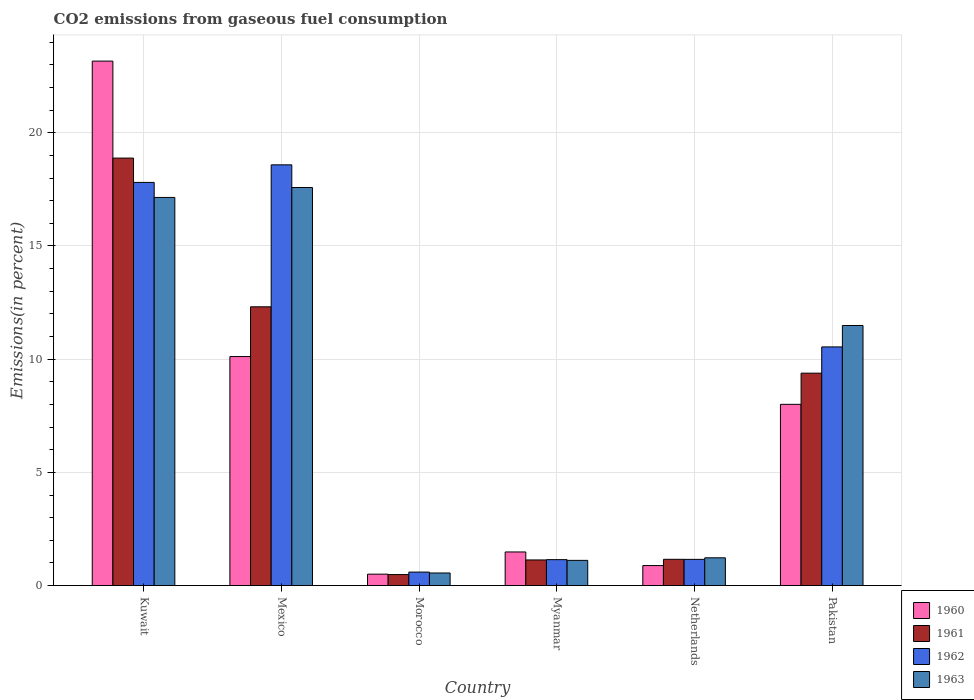How many groups of bars are there?
Give a very brief answer. 6. How many bars are there on the 6th tick from the left?
Ensure brevity in your answer.  4. How many bars are there on the 4th tick from the right?
Offer a very short reply. 4. What is the total CO2 emitted in 1961 in Kuwait?
Keep it short and to the point. 18.88. Across all countries, what is the maximum total CO2 emitted in 1961?
Your answer should be very brief. 18.88. Across all countries, what is the minimum total CO2 emitted in 1962?
Your response must be concise. 0.6. In which country was the total CO2 emitted in 1962 minimum?
Your answer should be compact. Morocco. What is the total total CO2 emitted in 1963 in the graph?
Your answer should be compact. 49.11. What is the difference between the total CO2 emitted in 1960 in Mexico and that in Netherlands?
Provide a short and direct response. 9.23. What is the difference between the total CO2 emitted in 1961 in Netherlands and the total CO2 emitted in 1962 in Kuwait?
Your response must be concise. -16.65. What is the average total CO2 emitted in 1962 per country?
Keep it short and to the point. 8.31. What is the difference between the total CO2 emitted of/in 1960 and total CO2 emitted of/in 1961 in Myanmar?
Ensure brevity in your answer.  0.35. What is the ratio of the total CO2 emitted in 1962 in Mexico to that in Pakistan?
Make the answer very short. 1.76. Is the total CO2 emitted in 1961 in Kuwait less than that in Mexico?
Provide a short and direct response. No. What is the difference between the highest and the second highest total CO2 emitted in 1961?
Offer a terse response. -9.5. What is the difference between the highest and the lowest total CO2 emitted in 1961?
Give a very brief answer. 18.4. In how many countries, is the total CO2 emitted in 1960 greater than the average total CO2 emitted in 1960 taken over all countries?
Provide a succinct answer. 3. What does the 3rd bar from the left in Pakistan represents?
Your response must be concise. 1962. Is it the case that in every country, the sum of the total CO2 emitted in 1962 and total CO2 emitted in 1961 is greater than the total CO2 emitted in 1960?
Offer a very short reply. Yes. How many bars are there?
Keep it short and to the point. 24. Are the values on the major ticks of Y-axis written in scientific E-notation?
Provide a short and direct response. No. Does the graph contain grids?
Provide a succinct answer. Yes. How many legend labels are there?
Your answer should be compact. 4. What is the title of the graph?
Offer a very short reply. CO2 emissions from gaseous fuel consumption. What is the label or title of the Y-axis?
Make the answer very short. Emissions(in percent). What is the Emissions(in percent) of 1960 in Kuwait?
Offer a very short reply. 23.17. What is the Emissions(in percent) of 1961 in Kuwait?
Ensure brevity in your answer.  18.88. What is the Emissions(in percent) in 1962 in Kuwait?
Your answer should be very brief. 17.81. What is the Emissions(in percent) in 1963 in Kuwait?
Your answer should be very brief. 17.14. What is the Emissions(in percent) of 1960 in Mexico?
Offer a terse response. 10.12. What is the Emissions(in percent) of 1961 in Mexico?
Your response must be concise. 12.31. What is the Emissions(in percent) in 1962 in Mexico?
Your answer should be very brief. 18.59. What is the Emissions(in percent) of 1963 in Mexico?
Offer a terse response. 17.58. What is the Emissions(in percent) of 1960 in Morocco?
Your answer should be very brief. 0.5. What is the Emissions(in percent) of 1961 in Morocco?
Keep it short and to the point. 0.49. What is the Emissions(in percent) in 1962 in Morocco?
Give a very brief answer. 0.6. What is the Emissions(in percent) of 1963 in Morocco?
Your answer should be very brief. 0.56. What is the Emissions(in percent) of 1960 in Myanmar?
Your answer should be very brief. 1.48. What is the Emissions(in percent) in 1961 in Myanmar?
Make the answer very short. 1.13. What is the Emissions(in percent) of 1962 in Myanmar?
Offer a terse response. 1.15. What is the Emissions(in percent) of 1963 in Myanmar?
Offer a terse response. 1.11. What is the Emissions(in percent) in 1960 in Netherlands?
Keep it short and to the point. 0.88. What is the Emissions(in percent) in 1961 in Netherlands?
Your answer should be very brief. 1.16. What is the Emissions(in percent) in 1962 in Netherlands?
Offer a terse response. 1.16. What is the Emissions(in percent) of 1963 in Netherlands?
Provide a succinct answer. 1.23. What is the Emissions(in percent) in 1960 in Pakistan?
Give a very brief answer. 8.01. What is the Emissions(in percent) in 1961 in Pakistan?
Your answer should be compact. 9.38. What is the Emissions(in percent) in 1962 in Pakistan?
Provide a succinct answer. 10.54. What is the Emissions(in percent) of 1963 in Pakistan?
Provide a succinct answer. 11.49. Across all countries, what is the maximum Emissions(in percent) in 1960?
Keep it short and to the point. 23.17. Across all countries, what is the maximum Emissions(in percent) in 1961?
Keep it short and to the point. 18.88. Across all countries, what is the maximum Emissions(in percent) in 1962?
Make the answer very short. 18.59. Across all countries, what is the maximum Emissions(in percent) of 1963?
Give a very brief answer. 17.58. Across all countries, what is the minimum Emissions(in percent) in 1960?
Ensure brevity in your answer.  0.5. Across all countries, what is the minimum Emissions(in percent) of 1961?
Offer a terse response. 0.49. Across all countries, what is the minimum Emissions(in percent) in 1962?
Make the answer very short. 0.6. Across all countries, what is the minimum Emissions(in percent) in 1963?
Make the answer very short. 0.56. What is the total Emissions(in percent) in 1960 in the graph?
Your answer should be very brief. 44.16. What is the total Emissions(in percent) in 1961 in the graph?
Provide a succinct answer. 43.36. What is the total Emissions(in percent) of 1962 in the graph?
Your response must be concise. 49.83. What is the total Emissions(in percent) in 1963 in the graph?
Your answer should be compact. 49.11. What is the difference between the Emissions(in percent) in 1960 in Kuwait and that in Mexico?
Offer a terse response. 13.05. What is the difference between the Emissions(in percent) in 1961 in Kuwait and that in Mexico?
Make the answer very short. 6.57. What is the difference between the Emissions(in percent) of 1962 in Kuwait and that in Mexico?
Make the answer very short. -0.78. What is the difference between the Emissions(in percent) of 1963 in Kuwait and that in Mexico?
Keep it short and to the point. -0.44. What is the difference between the Emissions(in percent) of 1960 in Kuwait and that in Morocco?
Provide a succinct answer. 22.66. What is the difference between the Emissions(in percent) in 1961 in Kuwait and that in Morocco?
Your answer should be very brief. 18.4. What is the difference between the Emissions(in percent) of 1962 in Kuwait and that in Morocco?
Provide a succinct answer. 17.21. What is the difference between the Emissions(in percent) in 1963 in Kuwait and that in Morocco?
Ensure brevity in your answer.  16.59. What is the difference between the Emissions(in percent) of 1960 in Kuwait and that in Myanmar?
Your response must be concise. 21.68. What is the difference between the Emissions(in percent) in 1961 in Kuwait and that in Myanmar?
Offer a terse response. 17.75. What is the difference between the Emissions(in percent) in 1962 in Kuwait and that in Myanmar?
Your answer should be compact. 16.66. What is the difference between the Emissions(in percent) in 1963 in Kuwait and that in Myanmar?
Ensure brevity in your answer.  16.03. What is the difference between the Emissions(in percent) of 1960 in Kuwait and that in Netherlands?
Your response must be concise. 22.28. What is the difference between the Emissions(in percent) in 1961 in Kuwait and that in Netherlands?
Ensure brevity in your answer.  17.72. What is the difference between the Emissions(in percent) of 1962 in Kuwait and that in Netherlands?
Make the answer very short. 16.65. What is the difference between the Emissions(in percent) of 1963 in Kuwait and that in Netherlands?
Your response must be concise. 15.92. What is the difference between the Emissions(in percent) of 1960 in Kuwait and that in Pakistan?
Ensure brevity in your answer.  15.16. What is the difference between the Emissions(in percent) in 1961 in Kuwait and that in Pakistan?
Provide a short and direct response. 9.5. What is the difference between the Emissions(in percent) of 1962 in Kuwait and that in Pakistan?
Offer a very short reply. 7.27. What is the difference between the Emissions(in percent) of 1963 in Kuwait and that in Pakistan?
Keep it short and to the point. 5.66. What is the difference between the Emissions(in percent) of 1960 in Mexico and that in Morocco?
Your answer should be very brief. 9.61. What is the difference between the Emissions(in percent) in 1961 in Mexico and that in Morocco?
Provide a succinct answer. 11.83. What is the difference between the Emissions(in percent) in 1962 in Mexico and that in Morocco?
Offer a very short reply. 17.99. What is the difference between the Emissions(in percent) of 1963 in Mexico and that in Morocco?
Provide a short and direct response. 17.03. What is the difference between the Emissions(in percent) of 1960 in Mexico and that in Myanmar?
Keep it short and to the point. 8.63. What is the difference between the Emissions(in percent) in 1961 in Mexico and that in Myanmar?
Offer a very short reply. 11.18. What is the difference between the Emissions(in percent) of 1962 in Mexico and that in Myanmar?
Provide a succinct answer. 17.44. What is the difference between the Emissions(in percent) in 1963 in Mexico and that in Myanmar?
Give a very brief answer. 16.47. What is the difference between the Emissions(in percent) in 1960 in Mexico and that in Netherlands?
Give a very brief answer. 9.23. What is the difference between the Emissions(in percent) of 1961 in Mexico and that in Netherlands?
Your answer should be compact. 11.15. What is the difference between the Emissions(in percent) of 1962 in Mexico and that in Netherlands?
Make the answer very short. 17.43. What is the difference between the Emissions(in percent) in 1963 in Mexico and that in Netherlands?
Provide a succinct answer. 16.36. What is the difference between the Emissions(in percent) of 1960 in Mexico and that in Pakistan?
Your answer should be very brief. 2.11. What is the difference between the Emissions(in percent) in 1961 in Mexico and that in Pakistan?
Offer a terse response. 2.93. What is the difference between the Emissions(in percent) in 1962 in Mexico and that in Pakistan?
Your answer should be compact. 8.04. What is the difference between the Emissions(in percent) in 1963 in Mexico and that in Pakistan?
Offer a very short reply. 6.1. What is the difference between the Emissions(in percent) of 1960 in Morocco and that in Myanmar?
Offer a very short reply. -0.98. What is the difference between the Emissions(in percent) of 1961 in Morocco and that in Myanmar?
Your answer should be very brief. -0.65. What is the difference between the Emissions(in percent) of 1962 in Morocco and that in Myanmar?
Offer a very short reply. -0.55. What is the difference between the Emissions(in percent) of 1963 in Morocco and that in Myanmar?
Your answer should be very brief. -0.56. What is the difference between the Emissions(in percent) in 1960 in Morocco and that in Netherlands?
Make the answer very short. -0.38. What is the difference between the Emissions(in percent) in 1961 in Morocco and that in Netherlands?
Your answer should be very brief. -0.67. What is the difference between the Emissions(in percent) in 1962 in Morocco and that in Netherlands?
Give a very brief answer. -0.56. What is the difference between the Emissions(in percent) of 1963 in Morocco and that in Netherlands?
Your response must be concise. -0.67. What is the difference between the Emissions(in percent) in 1960 in Morocco and that in Pakistan?
Keep it short and to the point. -7.5. What is the difference between the Emissions(in percent) of 1961 in Morocco and that in Pakistan?
Provide a succinct answer. -8.9. What is the difference between the Emissions(in percent) in 1962 in Morocco and that in Pakistan?
Give a very brief answer. -9.95. What is the difference between the Emissions(in percent) in 1963 in Morocco and that in Pakistan?
Your answer should be very brief. -10.93. What is the difference between the Emissions(in percent) in 1960 in Myanmar and that in Netherlands?
Offer a terse response. 0.6. What is the difference between the Emissions(in percent) in 1961 in Myanmar and that in Netherlands?
Your answer should be compact. -0.03. What is the difference between the Emissions(in percent) of 1962 in Myanmar and that in Netherlands?
Your response must be concise. -0.01. What is the difference between the Emissions(in percent) of 1963 in Myanmar and that in Netherlands?
Give a very brief answer. -0.11. What is the difference between the Emissions(in percent) in 1960 in Myanmar and that in Pakistan?
Ensure brevity in your answer.  -6.52. What is the difference between the Emissions(in percent) of 1961 in Myanmar and that in Pakistan?
Offer a terse response. -8.25. What is the difference between the Emissions(in percent) in 1962 in Myanmar and that in Pakistan?
Offer a terse response. -9.4. What is the difference between the Emissions(in percent) of 1963 in Myanmar and that in Pakistan?
Offer a very short reply. -10.37. What is the difference between the Emissions(in percent) in 1960 in Netherlands and that in Pakistan?
Give a very brief answer. -7.12. What is the difference between the Emissions(in percent) of 1961 in Netherlands and that in Pakistan?
Your response must be concise. -8.22. What is the difference between the Emissions(in percent) of 1962 in Netherlands and that in Pakistan?
Offer a very short reply. -9.38. What is the difference between the Emissions(in percent) of 1963 in Netherlands and that in Pakistan?
Keep it short and to the point. -10.26. What is the difference between the Emissions(in percent) of 1960 in Kuwait and the Emissions(in percent) of 1961 in Mexico?
Make the answer very short. 10.85. What is the difference between the Emissions(in percent) in 1960 in Kuwait and the Emissions(in percent) in 1962 in Mexico?
Provide a short and direct response. 4.58. What is the difference between the Emissions(in percent) in 1960 in Kuwait and the Emissions(in percent) in 1963 in Mexico?
Give a very brief answer. 5.58. What is the difference between the Emissions(in percent) in 1961 in Kuwait and the Emissions(in percent) in 1962 in Mexico?
Ensure brevity in your answer.  0.3. What is the difference between the Emissions(in percent) in 1961 in Kuwait and the Emissions(in percent) in 1963 in Mexico?
Make the answer very short. 1.3. What is the difference between the Emissions(in percent) in 1962 in Kuwait and the Emissions(in percent) in 1963 in Mexico?
Provide a short and direct response. 0.23. What is the difference between the Emissions(in percent) in 1960 in Kuwait and the Emissions(in percent) in 1961 in Morocco?
Provide a succinct answer. 22.68. What is the difference between the Emissions(in percent) of 1960 in Kuwait and the Emissions(in percent) of 1962 in Morocco?
Provide a succinct answer. 22.57. What is the difference between the Emissions(in percent) in 1960 in Kuwait and the Emissions(in percent) in 1963 in Morocco?
Make the answer very short. 22.61. What is the difference between the Emissions(in percent) of 1961 in Kuwait and the Emissions(in percent) of 1962 in Morocco?
Your answer should be compact. 18.29. What is the difference between the Emissions(in percent) in 1961 in Kuwait and the Emissions(in percent) in 1963 in Morocco?
Provide a short and direct response. 18.33. What is the difference between the Emissions(in percent) of 1962 in Kuwait and the Emissions(in percent) of 1963 in Morocco?
Give a very brief answer. 17.25. What is the difference between the Emissions(in percent) of 1960 in Kuwait and the Emissions(in percent) of 1961 in Myanmar?
Give a very brief answer. 22.04. What is the difference between the Emissions(in percent) of 1960 in Kuwait and the Emissions(in percent) of 1962 in Myanmar?
Make the answer very short. 22.02. What is the difference between the Emissions(in percent) in 1960 in Kuwait and the Emissions(in percent) in 1963 in Myanmar?
Provide a short and direct response. 22.05. What is the difference between the Emissions(in percent) of 1961 in Kuwait and the Emissions(in percent) of 1962 in Myanmar?
Ensure brevity in your answer.  17.74. What is the difference between the Emissions(in percent) of 1961 in Kuwait and the Emissions(in percent) of 1963 in Myanmar?
Ensure brevity in your answer.  17.77. What is the difference between the Emissions(in percent) of 1962 in Kuwait and the Emissions(in percent) of 1963 in Myanmar?
Offer a very short reply. 16.7. What is the difference between the Emissions(in percent) of 1960 in Kuwait and the Emissions(in percent) of 1961 in Netherlands?
Ensure brevity in your answer.  22.01. What is the difference between the Emissions(in percent) in 1960 in Kuwait and the Emissions(in percent) in 1962 in Netherlands?
Give a very brief answer. 22.01. What is the difference between the Emissions(in percent) of 1960 in Kuwait and the Emissions(in percent) of 1963 in Netherlands?
Give a very brief answer. 21.94. What is the difference between the Emissions(in percent) of 1961 in Kuwait and the Emissions(in percent) of 1962 in Netherlands?
Ensure brevity in your answer.  17.73. What is the difference between the Emissions(in percent) in 1961 in Kuwait and the Emissions(in percent) in 1963 in Netherlands?
Offer a very short reply. 17.66. What is the difference between the Emissions(in percent) in 1962 in Kuwait and the Emissions(in percent) in 1963 in Netherlands?
Offer a very short reply. 16.58. What is the difference between the Emissions(in percent) of 1960 in Kuwait and the Emissions(in percent) of 1961 in Pakistan?
Provide a short and direct response. 13.79. What is the difference between the Emissions(in percent) of 1960 in Kuwait and the Emissions(in percent) of 1962 in Pakistan?
Make the answer very short. 12.63. What is the difference between the Emissions(in percent) of 1960 in Kuwait and the Emissions(in percent) of 1963 in Pakistan?
Ensure brevity in your answer.  11.68. What is the difference between the Emissions(in percent) of 1961 in Kuwait and the Emissions(in percent) of 1962 in Pakistan?
Your answer should be compact. 8.34. What is the difference between the Emissions(in percent) in 1961 in Kuwait and the Emissions(in percent) in 1963 in Pakistan?
Give a very brief answer. 7.4. What is the difference between the Emissions(in percent) of 1962 in Kuwait and the Emissions(in percent) of 1963 in Pakistan?
Keep it short and to the point. 6.32. What is the difference between the Emissions(in percent) in 1960 in Mexico and the Emissions(in percent) in 1961 in Morocco?
Provide a short and direct response. 9.63. What is the difference between the Emissions(in percent) of 1960 in Mexico and the Emissions(in percent) of 1962 in Morocco?
Give a very brief answer. 9.52. What is the difference between the Emissions(in percent) in 1960 in Mexico and the Emissions(in percent) in 1963 in Morocco?
Your answer should be very brief. 9.56. What is the difference between the Emissions(in percent) of 1961 in Mexico and the Emissions(in percent) of 1962 in Morocco?
Offer a very short reply. 11.72. What is the difference between the Emissions(in percent) of 1961 in Mexico and the Emissions(in percent) of 1963 in Morocco?
Provide a succinct answer. 11.76. What is the difference between the Emissions(in percent) in 1962 in Mexico and the Emissions(in percent) in 1963 in Morocco?
Keep it short and to the point. 18.03. What is the difference between the Emissions(in percent) in 1960 in Mexico and the Emissions(in percent) in 1961 in Myanmar?
Give a very brief answer. 8.98. What is the difference between the Emissions(in percent) in 1960 in Mexico and the Emissions(in percent) in 1962 in Myanmar?
Offer a very short reply. 8.97. What is the difference between the Emissions(in percent) in 1960 in Mexico and the Emissions(in percent) in 1963 in Myanmar?
Provide a succinct answer. 9. What is the difference between the Emissions(in percent) of 1961 in Mexico and the Emissions(in percent) of 1962 in Myanmar?
Provide a succinct answer. 11.17. What is the difference between the Emissions(in percent) in 1961 in Mexico and the Emissions(in percent) in 1963 in Myanmar?
Make the answer very short. 11.2. What is the difference between the Emissions(in percent) of 1962 in Mexico and the Emissions(in percent) of 1963 in Myanmar?
Provide a short and direct response. 17.47. What is the difference between the Emissions(in percent) of 1960 in Mexico and the Emissions(in percent) of 1961 in Netherlands?
Offer a very short reply. 8.96. What is the difference between the Emissions(in percent) of 1960 in Mexico and the Emissions(in percent) of 1962 in Netherlands?
Your response must be concise. 8.96. What is the difference between the Emissions(in percent) in 1960 in Mexico and the Emissions(in percent) in 1963 in Netherlands?
Ensure brevity in your answer.  8.89. What is the difference between the Emissions(in percent) of 1961 in Mexico and the Emissions(in percent) of 1962 in Netherlands?
Your answer should be compact. 11.16. What is the difference between the Emissions(in percent) of 1961 in Mexico and the Emissions(in percent) of 1963 in Netherlands?
Your response must be concise. 11.09. What is the difference between the Emissions(in percent) in 1962 in Mexico and the Emissions(in percent) in 1963 in Netherlands?
Your answer should be very brief. 17.36. What is the difference between the Emissions(in percent) of 1960 in Mexico and the Emissions(in percent) of 1961 in Pakistan?
Offer a very short reply. 0.73. What is the difference between the Emissions(in percent) of 1960 in Mexico and the Emissions(in percent) of 1962 in Pakistan?
Offer a terse response. -0.43. What is the difference between the Emissions(in percent) of 1960 in Mexico and the Emissions(in percent) of 1963 in Pakistan?
Keep it short and to the point. -1.37. What is the difference between the Emissions(in percent) of 1961 in Mexico and the Emissions(in percent) of 1962 in Pakistan?
Offer a terse response. 1.77. What is the difference between the Emissions(in percent) in 1961 in Mexico and the Emissions(in percent) in 1963 in Pakistan?
Provide a succinct answer. 0.83. What is the difference between the Emissions(in percent) in 1962 in Mexico and the Emissions(in percent) in 1963 in Pakistan?
Your answer should be very brief. 7.1. What is the difference between the Emissions(in percent) in 1960 in Morocco and the Emissions(in percent) in 1961 in Myanmar?
Your answer should be compact. -0.63. What is the difference between the Emissions(in percent) of 1960 in Morocco and the Emissions(in percent) of 1962 in Myanmar?
Your response must be concise. -0.64. What is the difference between the Emissions(in percent) in 1960 in Morocco and the Emissions(in percent) in 1963 in Myanmar?
Offer a terse response. -0.61. What is the difference between the Emissions(in percent) of 1961 in Morocco and the Emissions(in percent) of 1962 in Myanmar?
Give a very brief answer. -0.66. What is the difference between the Emissions(in percent) in 1961 in Morocco and the Emissions(in percent) in 1963 in Myanmar?
Provide a short and direct response. -0.63. What is the difference between the Emissions(in percent) in 1962 in Morocco and the Emissions(in percent) in 1963 in Myanmar?
Ensure brevity in your answer.  -0.52. What is the difference between the Emissions(in percent) of 1960 in Morocco and the Emissions(in percent) of 1961 in Netherlands?
Provide a succinct answer. -0.66. What is the difference between the Emissions(in percent) of 1960 in Morocco and the Emissions(in percent) of 1962 in Netherlands?
Offer a terse response. -0.65. What is the difference between the Emissions(in percent) of 1960 in Morocco and the Emissions(in percent) of 1963 in Netherlands?
Keep it short and to the point. -0.72. What is the difference between the Emissions(in percent) in 1961 in Morocco and the Emissions(in percent) in 1962 in Netherlands?
Keep it short and to the point. -0.67. What is the difference between the Emissions(in percent) in 1961 in Morocco and the Emissions(in percent) in 1963 in Netherlands?
Your response must be concise. -0.74. What is the difference between the Emissions(in percent) in 1962 in Morocco and the Emissions(in percent) in 1963 in Netherlands?
Your answer should be compact. -0.63. What is the difference between the Emissions(in percent) of 1960 in Morocco and the Emissions(in percent) of 1961 in Pakistan?
Your response must be concise. -8.88. What is the difference between the Emissions(in percent) in 1960 in Morocco and the Emissions(in percent) in 1962 in Pakistan?
Your answer should be compact. -10.04. What is the difference between the Emissions(in percent) of 1960 in Morocco and the Emissions(in percent) of 1963 in Pakistan?
Your answer should be compact. -10.98. What is the difference between the Emissions(in percent) in 1961 in Morocco and the Emissions(in percent) in 1962 in Pakistan?
Provide a short and direct response. -10.06. What is the difference between the Emissions(in percent) of 1961 in Morocco and the Emissions(in percent) of 1963 in Pakistan?
Offer a terse response. -11. What is the difference between the Emissions(in percent) in 1962 in Morocco and the Emissions(in percent) in 1963 in Pakistan?
Make the answer very short. -10.89. What is the difference between the Emissions(in percent) in 1960 in Myanmar and the Emissions(in percent) in 1961 in Netherlands?
Your answer should be compact. 0.32. What is the difference between the Emissions(in percent) in 1960 in Myanmar and the Emissions(in percent) in 1962 in Netherlands?
Ensure brevity in your answer.  0.33. What is the difference between the Emissions(in percent) in 1960 in Myanmar and the Emissions(in percent) in 1963 in Netherlands?
Your answer should be very brief. 0.26. What is the difference between the Emissions(in percent) in 1961 in Myanmar and the Emissions(in percent) in 1962 in Netherlands?
Offer a terse response. -0.03. What is the difference between the Emissions(in percent) in 1961 in Myanmar and the Emissions(in percent) in 1963 in Netherlands?
Provide a short and direct response. -0.09. What is the difference between the Emissions(in percent) of 1962 in Myanmar and the Emissions(in percent) of 1963 in Netherlands?
Keep it short and to the point. -0.08. What is the difference between the Emissions(in percent) of 1960 in Myanmar and the Emissions(in percent) of 1961 in Pakistan?
Make the answer very short. -7.9. What is the difference between the Emissions(in percent) in 1960 in Myanmar and the Emissions(in percent) in 1962 in Pakistan?
Ensure brevity in your answer.  -9.06. What is the difference between the Emissions(in percent) in 1960 in Myanmar and the Emissions(in percent) in 1963 in Pakistan?
Ensure brevity in your answer.  -10. What is the difference between the Emissions(in percent) of 1961 in Myanmar and the Emissions(in percent) of 1962 in Pakistan?
Make the answer very short. -9.41. What is the difference between the Emissions(in percent) in 1961 in Myanmar and the Emissions(in percent) in 1963 in Pakistan?
Your answer should be very brief. -10.36. What is the difference between the Emissions(in percent) of 1962 in Myanmar and the Emissions(in percent) of 1963 in Pakistan?
Keep it short and to the point. -10.34. What is the difference between the Emissions(in percent) in 1960 in Netherlands and the Emissions(in percent) in 1961 in Pakistan?
Your response must be concise. -8.5. What is the difference between the Emissions(in percent) in 1960 in Netherlands and the Emissions(in percent) in 1962 in Pakistan?
Your answer should be very brief. -9.66. What is the difference between the Emissions(in percent) of 1960 in Netherlands and the Emissions(in percent) of 1963 in Pakistan?
Provide a short and direct response. -10.6. What is the difference between the Emissions(in percent) in 1961 in Netherlands and the Emissions(in percent) in 1962 in Pakistan?
Give a very brief answer. -9.38. What is the difference between the Emissions(in percent) in 1961 in Netherlands and the Emissions(in percent) in 1963 in Pakistan?
Ensure brevity in your answer.  -10.33. What is the difference between the Emissions(in percent) in 1962 in Netherlands and the Emissions(in percent) in 1963 in Pakistan?
Offer a terse response. -10.33. What is the average Emissions(in percent) of 1960 per country?
Your response must be concise. 7.36. What is the average Emissions(in percent) in 1961 per country?
Provide a succinct answer. 7.23. What is the average Emissions(in percent) in 1962 per country?
Offer a very short reply. 8.31. What is the average Emissions(in percent) of 1963 per country?
Your answer should be compact. 8.18. What is the difference between the Emissions(in percent) in 1960 and Emissions(in percent) in 1961 in Kuwait?
Provide a short and direct response. 4.28. What is the difference between the Emissions(in percent) of 1960 and Emissions(in percent) of 1962 in Kuwait?
Make the answer very short. 5.36. What is the difference between the Emissions(in percent) in 1960 and Emissions(in percent) in 1963 in Kuwait?
Keep it short and to the point. 6.02. What is the difference between the Emissions(in percent) in 1961 and Emissions(in percent) in 1962 in Kuwait?
Make the answer very short. 1.07. What is the difference between the Emissions(in percent) in 1961 and Emissions(in percent) in 1963 in Kuwait?
Ensure brevity in your answer.  1.74. What is the difference between the Emissions(in percent) of 1962 and Emissions(in percent) of 1963 in Kuwait?
Ensure brevity in your answer.  0.66. What is the difference between the Emissions(in percent) in 1960 and Emissions(in percent) in 1961 in Mexico?
Provide a short and direct response. -2.2. What is the difference between the Emissions(in percent) in 1960 and Emissions(in percent) in 1962 in Mexico?
Provide a short and direct response. -8.47. What is the difference between the Emissions(in percent) in 1960 and Emissions(in percent) in 1963 in Mexico?
Keep it short and to the point. -7.47. What is the difference between the Emissions(in percent) of 1961 and Emissions(in percent) of 1962 in Mexico?
Make the answer very short. -6.27. What is the difference between the Emissions(in percent) of 1961 and Emissions(in percent) of 1963 in Mexico?
Offer a terse response. -5.27. What is the difference between the Emissions(in percent) of 1962 and Emissions(in percent) of 1963 in Mexico?
Your answer should be very brief. 1. What is the difference between the Emissions(in percent) of 1960 and Emissions(in percent) of 1961 in Morocco?
Offer a very short reply. 0.02. What is the difference between the Emissions(in percent) in 1960 and Emissions(in percent) in 1962 in Morocco?
Your answer should be compact. -0.09. What is the difference between the Emissions(in percent) of 1960 and Emissions(in percent) of 1963 in Morocco?
Keep it short and to the point. -0.05. What is the difference between the Emissions(in percent) of 1961 and Emissions(in percent) of 1962 in Morocco?
Keep it short and to the point. -0.11. What is the difference between the Emissions(in percent) in 1961 and Emissions(in percent) in 1963 in Morocco?
Keep it short and to the point. -0.07. What is the difference between the Emissions(in percent) of 1962 and Emissions(in percent) of 1963 in Morocco?
Your response must be concise. 0.04. What is the difference between the Emissions(in percent) in 1960 and Emissions(in percent) in 1961 in Myanmar?
Keep it short and to the point. 0.35. What is the difference between the Emissions(in percent) in 1960 and Emissions(in percent) in 1962 in Myanmar?
Make the answer very short. 0.34. What is the difference between the Emissions(in percent) in 1960 and Emissions(in percent) in 1963 in Myanmar?
Keep it short and to the point. 0.37. What is the difference between the Emissions(in percent) of 1961 and Emissions(in percent) of 1962 in Myanmar?
Ensure brevity in your answer.  -0.01. What is the difference between the Emissions(in percent) in 1961 and Emissions(in percent) in 1963 in Myanmar?
Offer a terse response. 0.02. What is the difference between the Emissions(in percent) in 1962 and Emissions(in percent) in 1963 in Myanmar?
Offer a very short reply. 0.03. What is the difference between the Emissions(in percent) in 1960 and Emissions(in percent) in 1961 in Netherlands?
Provide a succinct answer. -0.28. What is the difference between the Emissions(in percent) in 1960 and Emissions(in percent) in 1962 in Netherlands?
Offer a very short reply. -0.27. What is the difference between the Emissions(in percent) in 1960 and Emissions(in percent) in 1963 in Netherlands?
Your response must be concise. -0.34. What is the difference between the Emissions(in percent) in 1961 and Emissions(in percent) in 1962 in Netherlands?
Your answer should be very brief. 0. What is the difference between the Emissions(in percent) in 1961 and Emissions(in percent) in 1963 in Netherlands?
Your answer should be compact. -0.07. What is the difference between the Emissions(in percent) in 1962 and Emissions(in percent) in 1963 in Netherlands?
Give a very brief answer. -0.07. What is the difference between the Emissions(in percent) in 1960 and Emissions(in percent) in 1961 in Pakistan?
Provide a succinct answer. -1.38. What is the difference between the Emissions(in percent) in 1960 and Emissions(in percent) in 1962 in Pakistan?
Ensure brevity in your answer.  -2.54. What is the difference between the Emissions(in percent) in 1960 and Emissions(in percent) in 1963 in Pakistan?
Offer a very short reply. -3.48. What is the difference between the Emissions(in percent) in 1961 and Emissions(in percent) in 1962 in Pakistan?
Your answer should be very brief. -1.16. What is the difference between the Emissions(in percent) of 1961 and Emissions(in percent) of 1963 in Pakistan?
Offer a very short reply. -2.11. What is the difference between the Emissions(in percent) in 1962 and Emissions(in percent) in 1963 in Pakistan?
Give a very brief answer. -0.95. What is the ratio of the Emissions(in percent) in 1960 in Kuwait to that in Mexico?
Provide a short and direct response. 2.29. What is the ratio of the Emissions(in percent) in 1961 in Kuwait to that in Mexico?
Offer a terse response. 1.53. What is the ratio of the Emissions(in percent) of 1962 in Kuwait to that in Mexico?
Ensure brevity in your answer.  0.96. What is the ratio of the Emissions(in percent) in 1963 in Kuwait to that in Mexico?
Make the answer very short. 0.97. What is the ratio of the Emissions(in percent) of 1960 in Kuwait to that in Morocco?
Provide a short and direct response. 46.01. What is the ratio of the Emissions(in percent) of 1961 in Kuwait to that in Morocco?
Provide a succinct answer. 38.9. What is the ratio of the Emissions(in percent) of 1962 in Kuwait to that in Morocco?
Your answer should be very brief. 29.92. What is the ratio of the Emissions(in percent) of 1963 in Kuwait to that in Morocco?
Ensure brevity in your answer.  30.86. What is the ratio of the Emissions(in percent) of 1960 in Kuwait to that in Myanmar?
Your answer should be compact. 15.61. What is the ratio of the Emissions(in percent) in 1961 in Kuwait to that in Myanmar?
Make the answer very short. 16.69. What is the ratio of the Emissions(in percent) in 1962 in Kuwait to that in Myanmar?
Your answer should be very brief. 15.55. What is the ratio of the Emissions(in percent) of 1963 in Kuwait to that in Myanmar?
Your answer should be compact. 15.41. What is the ratio of the Emissions(in percent) in 1960 in Kuwait to that in Netherlands?
Your answer should be very brief. 26.24. What is the ratio of the Emissions(in percent) of 1961 in Kuwait to that in Netherlands?
Offer a terse response. 16.28. What is the ratio of the Emissions(in percent) of 1962 in Kuwait to that in Netherlands?
Offer a terse response. 15.39. What is the ratio of the Emissions(in percent) in 1963 in Kuwait to that in Netherlands?
Provide a succinct answer. 13.98. What is the ratio of the Emissions(in percent) in 1960 in Kuwait to that in Pakistan?
Ensure brevity in your answer.  2.89. What is the ratio of the Emissions(in percent) in 1961 in Kuwait to that in Pakistan?
Offer a very short reply. 2.01. What is the ratio of the Emissions(in percent) in 1962 in Kuwait to that in Pakistan?
Ensure brevity in your answer.  1.69. What is the ratio of the Emissions(in percent) in 1963 in Kuwait to that in Pakistan?
Offer a very short reply. 1.49. What is the ratio of the Emissions(in percent) of 1960 in Mexico to that in Morocco?
Your response must be concise. 20.09. What is the ratio of the Emissions(in percent) of 1961 in Mexico to that in Morocco?
Offer a very short reply. 25.37. What is the ratio of the Emissions(in percent) of 1962 in Mexico to that in Morocco?
Your answer should be very brief. 31.22. What is the ratio of the Emissions(in percent) of 1963 in Mexico to that in Morocco?
Make the answer very short. 31.65. What is the ratio of the Emissions(in percent) in 1960 in Mexico to that in Myanmar?
Your answer should be compact. 6.81. What is the ratio of the Emissions(in percent) of 1961 in Mexico to that in Myanmar?
Provide a short and direct response. 10.88. What is the ratio of the Emissions(in percent) in 1962 in Mexico to that in Myanmar?
Your response must be concise. 16.23. What is the ratio of the Emissions(in percent) in 1963 in Mexico to that in Myanmar?
Keep it short and to the point. 15.8. What is the ratio of the Emissions(in percent) in 1960 in Mexico to that in Netherlands?
Offer a terse response. 11.46. What is the ratio of the Emissions(in percent) in 1961 in Mexico to that in Netherlands?
Give a very brief answer. 10.62. What is the ratio of the Emissions(in percent) in 1962 in Mexico to that in Netherlands?
Provide a succinct answer. 16.06. What is the ratio of the Emissions(in percent) in 1963 in Mexico to that in Netherlands?
Your answer should be very brief. 14.34. What is the ratio of the Emissions(in percent) in 1960 in Mexico to that in Pakistan?
Provide a succinct answer. 1.26. What is the ratio of the Emissions(in percent) of 1961 in Mexico to that in Pakistan?
Make the answer very short. 1.31. What is the ratio of the Emissions(in percent) of 1962 in Mexico to that in Pakistan?
Offer a terse response. 1.76. What is the ratio of the Emissions(in percent) in 1963 in Mexico to that in Pakistan?
Your answer should be compact. 1.53. What is the ratio of the Emissions(in percent) in 1960 in Morocco to that in Myanmar?
Your answer should be very brief. 0.34. What is the ratio of the Emissions(in percent) of 1961 in Morocco to that in Myanmar?
Provide a succinct answer. 0.43. What is the ratio of the Emissions(in percent) in 1962 in Morocco to that in Myanmar?
Ensure brevity in your answer.  0.52. What is the ratio of the Emissions(in percent) of 1963 in Morocco to that in Myanmar?
Give a very brief answer. 0.5. What is the ratio of the Emissions(in percent) of 1960 in Morocco to that in Netherlands?
Your response must be concise. 0.57. What is the ratio of the Emissions(in percent) of 1961 in Morocco to that in Netherlands?
Keep it short and to the point. 0.42. What is the ratio of the Emissions(in percent) in 1962 in Morocco to that in Netherlands?
Your response must be concise. 0.51. What is the ratio of the Emissions(in percent) of 1963 in Morocco to that in Netherlands?
Keep it short and to the point. 0.45. What is the ratio of the Emissions(in percent) in 1960 in Morocco to that in Pakistan?
Offer a terse response. 0.06. What is the ratio of the Emissions(in percent) of 1961 in Morocco to that in Pakistan?
Keep it short and to the point. 0.05. What is the ratio of the Emissions(in percent) of 1962 in Morocco to that in Pakistan?
Ensure brevity in your answer.  0.06. What is the ratio of the Emissions(in percent) of 1963 in Morocco to that in Pakistan?
Offer a very short reply. 0.05. What is the ratio of the Emissions(in percent) in 1960 in Myanmar to that in Netherlands?
Offer a terse response. 1.68. What is the ratio of the Emissions(in percent) in 1961 in Myanmar to that in Netherlands?
Offer a terse response. 0.98. What is the ratio of the Emissions(in percent) of 1963 in Myanmar to that in Netherlands?
Your answer should be compact. 0.91. What is the ratio of the Emissions(in percent) in 1960 in Myanmar to that in Pakistan?
Your response must be concise. 0.19. What is the ratio of the Emissions(in percent) in 1961 in Myanmar to that in Pakistan?
Provide a short and direct response. 0.12. What is the ratio of the Emissions(in percent) in 1962 in Myanmar to that in Pakistan?
Provide a short and direct response. 0.11. What is the ratio of the Emissions(in percent) of 1963 in Myanmar to that in Pakistan?
Keep it short and to the point. 0.1. What is the ratio of the Emissions(in percent) in 1960 in Netherlands to that in Pakistan?
Your answer should be compact. 0.11. What is the ratio of the Emissions(in percent) of 1961 in Netherlands to that in Pakistan?
Offer a terse response. 0.12. What is the ratio of the Emissions(in percent) of 1962 in Netherlands to that in Pakistan?
Provide a succinct answer. 0.11. What is the ratio of the Emissions(in percent) of 1963 in Netherlands to that in Pakistan?
Offer a very short reply. 0.11. What is the difference between the highest and the second highest Emissions(in percent) of 1960?
Keep it short and to the point. 13.05. What is the difference between the highest and the second highest Emissions(in percent) in 1961?
Provide a succinct answer. 6.57. What is the difference between the highest and the second highest Emissions(in percent) of 1962?
Provide a short and direct response. 0.78. What is the difference between the highest and the second highest Emissions(in percent) of 1963?
Keep it short and to the point. 0.44. What is the difference between the highest and the lowest Emissions(in percent) of 1960?
Provide a short and direct response. 22.66. What is the difference between the highest and the lowest Emissions(in percent) of 1961?
Your answer should be very brief. 18.4. What is the difference between the highest and the lowest Emissions(in percent) in 1962?
Your answer should be very brief. 17.99. What is the difference between the highest and the lowest Emissions(in percent) of 1963?
Provide a succinct answer. 17.03. 